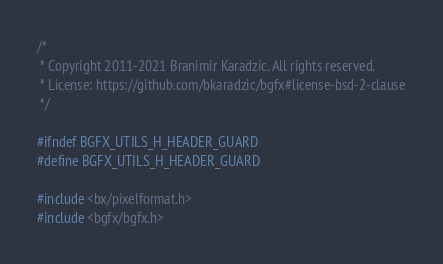<code> <loc_0><loc_0><loc_500><loc_500><_C_>/*
 * Copyright 2011-2021 Branimir Karadzic. All rights reserved.
 * License: https://github.com/bkaradzic/bgfx#license-bsd-2-clause
 */

#ifndef BGFX_UTILS_H_HEADER_GUARD
#define BGFX_UTILS_H_HEADER_GUARD

#include <bx/pixelformat.h>
#include <bgfx/bgfx.h></code> 